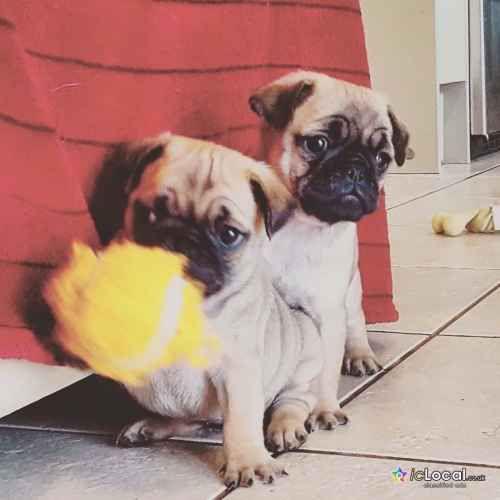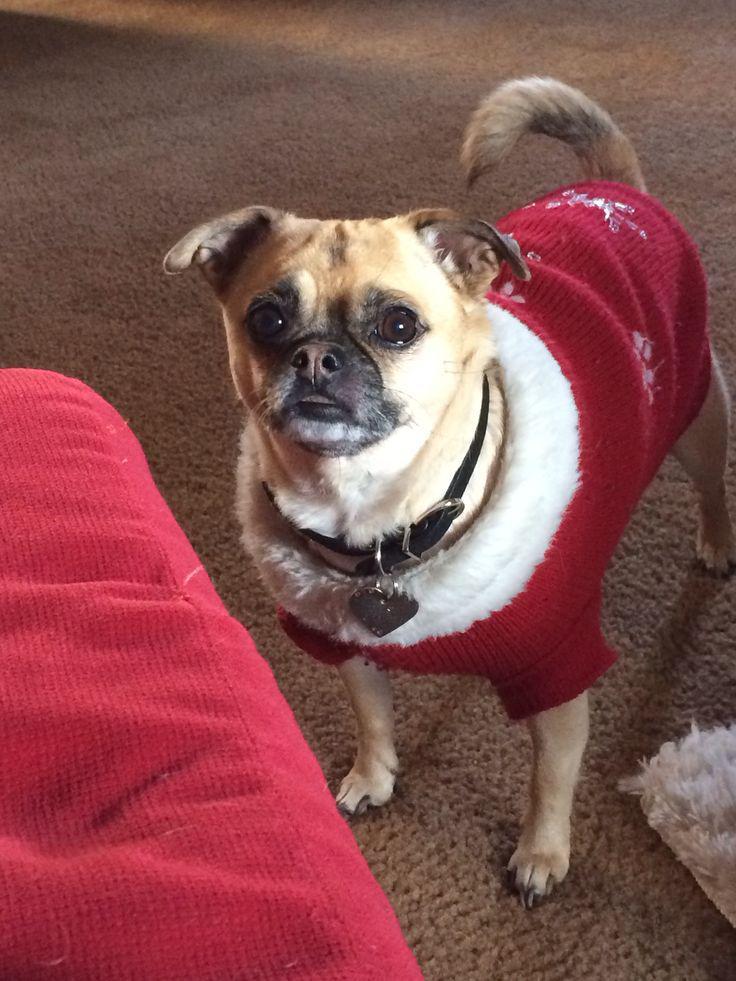The first image is the image on the left, the second image is the image on the right. Analyze the images presented: Is the assertion "There is a pug wearing something decorative and cute on his head." valid? Answer yes or no. No. The first image is the image on the left, the second image is the image on the right. For the images displayed, is the sentence "At least one of the pugs is wearing something on its head." factually correct? Answer yes or no. No. 